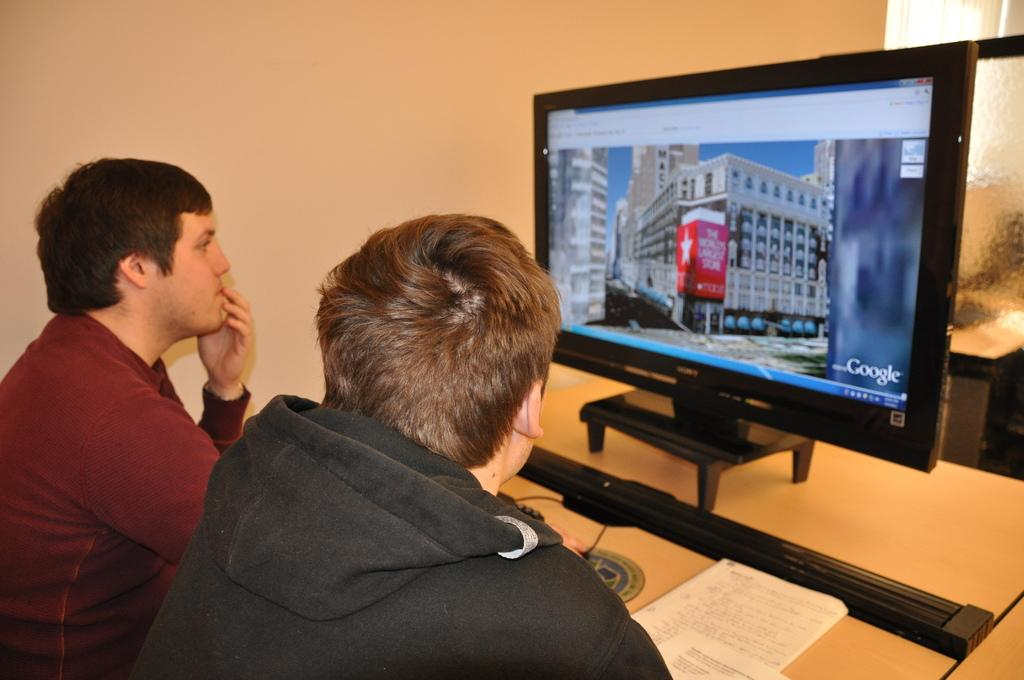Provide a one-sentence caption for the provided image. Two younger males explore the world's largest store via Google. 